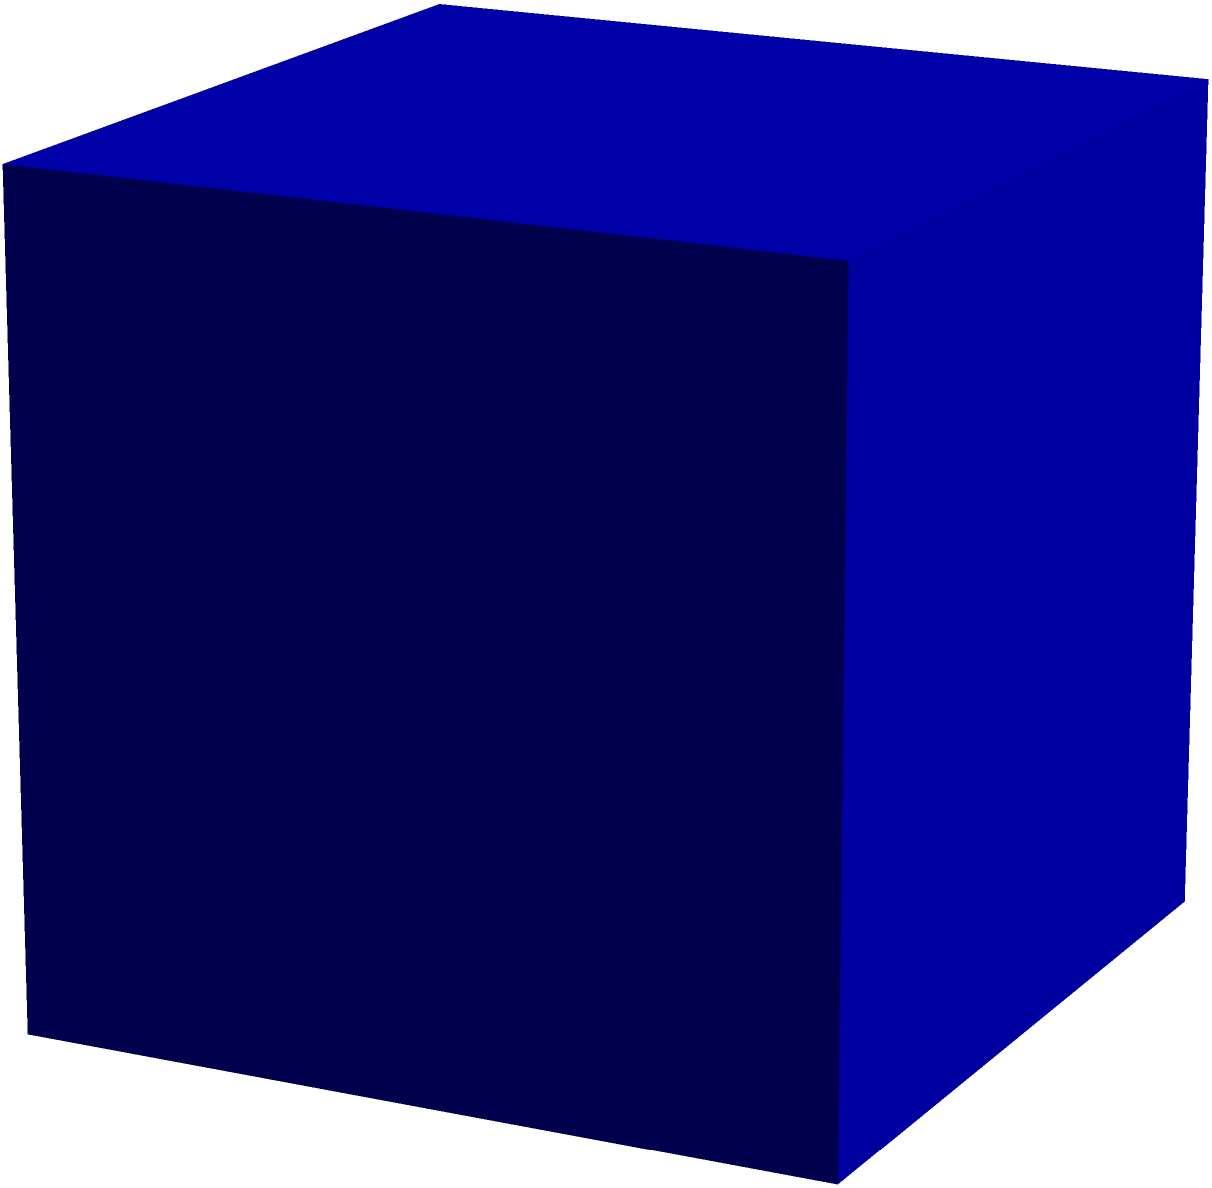A cube-shaped nutrient solution container has a side length of 30 cm. Calculate the total surface area of the container, which is crucial for determining the rate of nutrient absorption and evaporation in your hydroponic system. To find the total surface area of a cube, we need to calculate the area of all six faces and sum them up. Here's how we do it:

1. First, recall the formula for the surface area of a cube:
   $$ SA = 6a^2 $$
   where $SA$ is the surface area and $a$ is the length of one side.

2. We're given that the side length $a = 30$ cm.

3. Let's substitute this into our formula:
   $$ SA = 6 \times (30\text{ cm})^2 $$

4. Now, let's calculate:
   $$ SA = 6 \times 900\text{ cm}^2 = 5400\text{ cm}^2 $$

5. Therefore, the total surface area of the nutrient solution container is 5400 cm².

This surface area is important in hydroponics as it affects the rate of nutrient absorption and solution evaporation, which are critical factors in maintaining optimal plant nutrition.
Answer: $5400\text{ cm}^2$ 